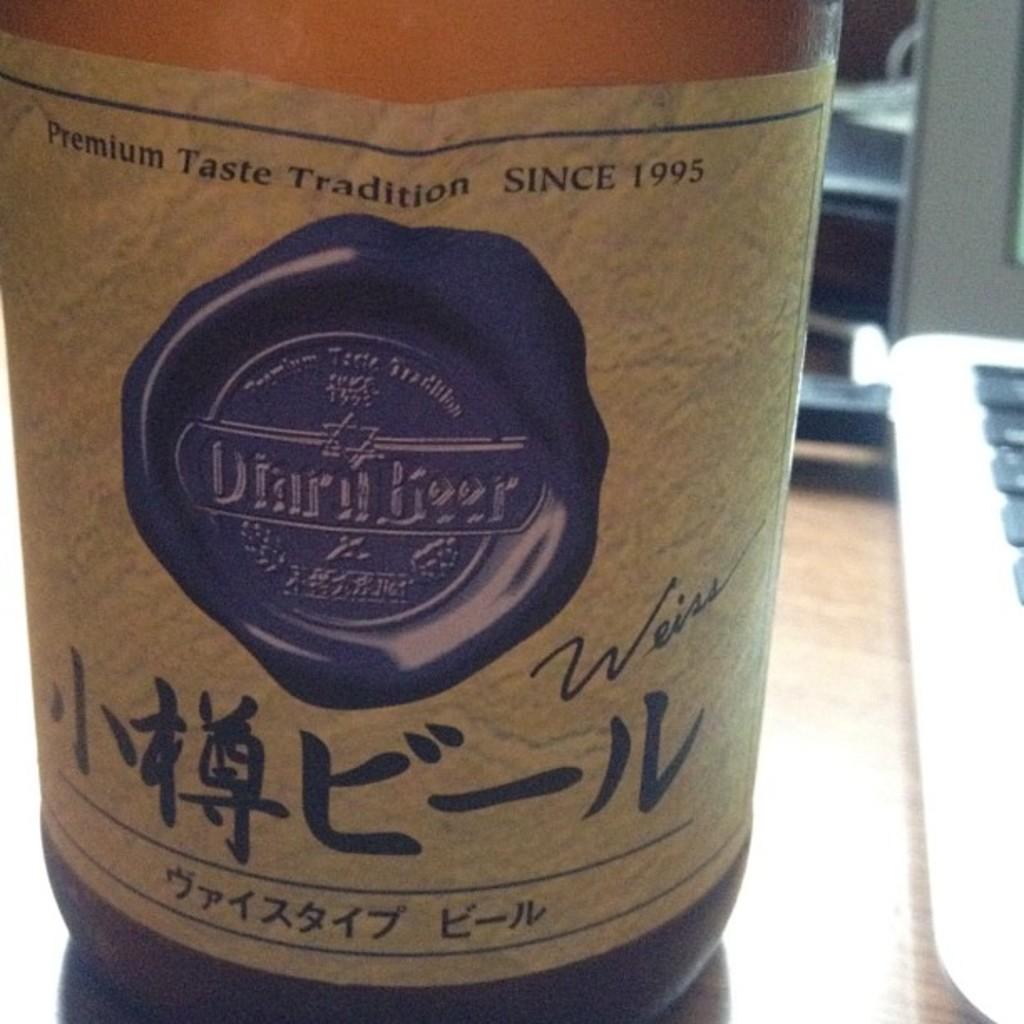What year is on the beer label?
Offer a terse response. 1995. 